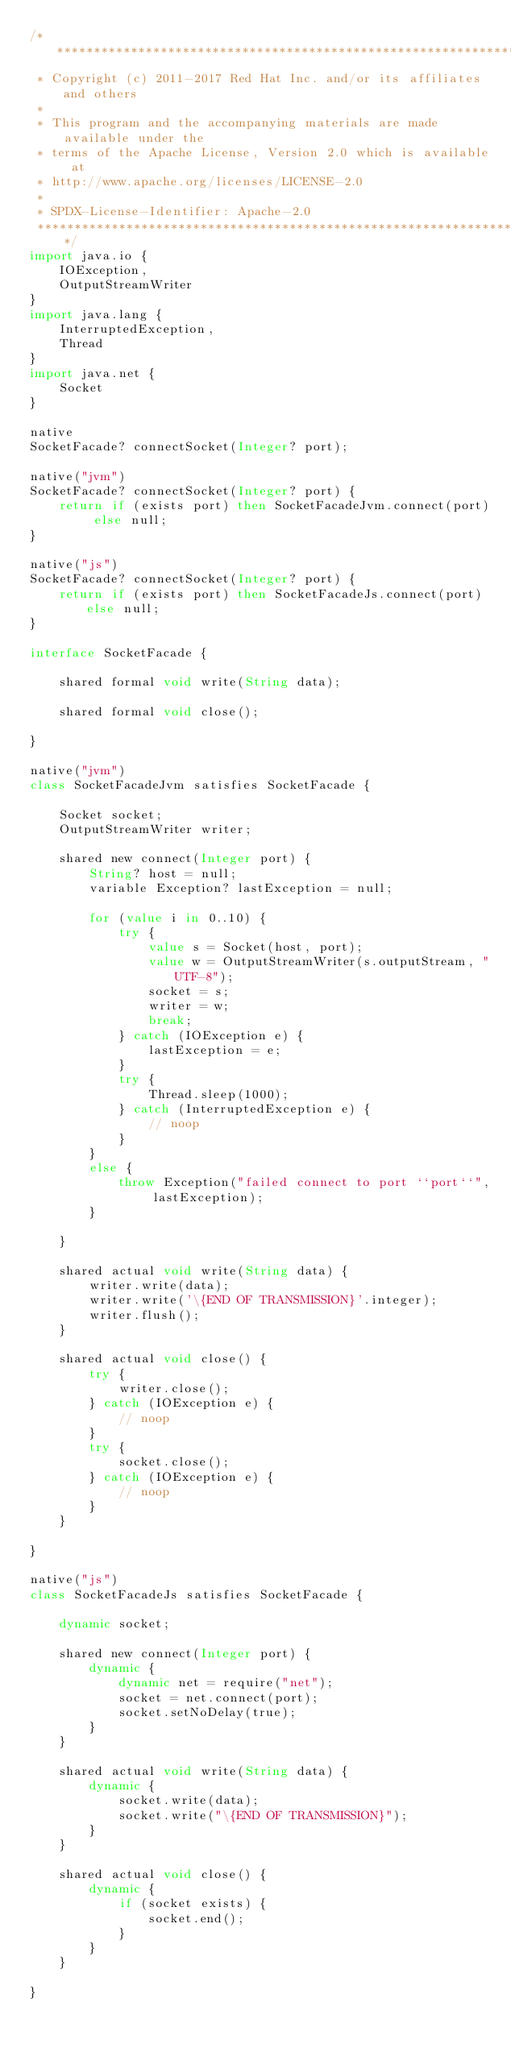<code> <loc_0><loc_0><loc_500><loc_500><_Ceylon_>/********************************************************************************
 * Copyright (c) 2011-2017 Red Hat Inc. and/or its affiliates and others
 *
 * This program and the accompanying materials are made available under the 
 * terms of the Apache License, Version 2.0 which is available at
 * http://www.apache.org/licenses/LICENSE-2.0
 *
 * SPDX-License-Identifier: Apache-2.0 
 ********************************************************************************/
import java.io {
    IOException,
    OutputStreamWriter
}
import java.lang {
    InterruptedException,
    Thread
}
import java.net {
    Socket
}

native
SocketFacade? connectSocket(Integer? port);

native("jvm")
SocketFacade? connectSocket(Integer? port) {
    return if (exists port) then SocketFacadeJvm.connect(port) else null;
}

native("js")
SocketFacade? connectSocket(Integer? port) {
    return if (exists port) then SocketFacadeJs.connect(port) else null;
}

interface SocketFacade {
    
    shared formal void write(String data);
    
    shared formal void close();
    
}

native("jvm")
class SocketFacadeJvm satisfies SocketFacade {
    
    Socket socket;
    OutputStreamWriter writer;
    
    shared new connect(Integer port) {
        String? host = null;
        variable Exception? lastException = null;
        
        for (value i in 0..10) {
            try {
                value s = Socket(host, port);
                value w = OutputStreamWriter(s.outputStream, "UTF-8");
                socket = s;
                writer = w;
                break;
            } catch (IOException e) {
                lastException = e;
            }
            try {
                Thread.sleep(1000);
            } catch (InterruptedException e) {
                // noop
            }
        }
        else {
            throw Exception("failed connect to port ``port``", lastException);
        }
        
    }
    
    shared actual void write(String data) {
        writer.write(data);
        writer.write('\{END OF TRANSMISSION}'.integer);
        writer.flush();
    }
    
    shared actual void close() {
        try {
            writer.close();
        } catch (IOException e) {
            // noop
        }
        try {
            socket.close();
        } catch (IOException e) {
            // noop
        }
    }
    
}

native("js")
class SocketFacadeJs satisfies SocketFacade {
    
    dynamic socket;
    
    shared new connect(Integer port) {
        dynamic {
            dynamic net = require("net");
            socket = net.connect(port);
            socket.setNoDelay(true);
        }
    }
    
    shared actual void write(String data) {
        dynamic {
            socket.write(data);
            socket.write("\{END OF TRANSMISSION}");
        }
    }
    
    shared actual void close() {
        dynamic {
            if (socket exists) {
                socket.end();
            }
        }
    }
    
}
</code> 